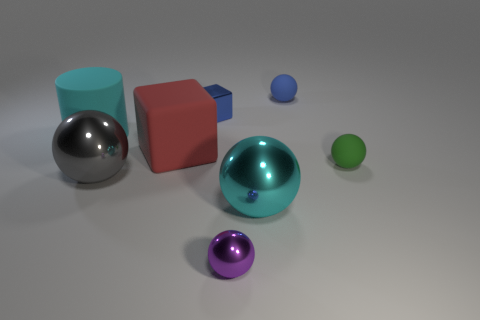Subtract all small matte balls. How many balls are left? 3 Add 1 big rubber cubes. How many objects exist? 9 Subtract all purple balls. How many balls are left? 4 Subtract 1 balls. How many balls are left? 4 Subtract all blocks. How many objects are left? 6 Subtract all red balls. Subtract all cyan cubes. How many balls are left? 5 Add 5 purple shiny things. How many purple shiny things are left? 6 Add 4 small rubber cylinders. How many small rubber cylinders exist? 4 Subtract 0 gray cylinders. How many objects are left? 8 Subtract all large blocks. Subtract all big cyan rubber things. How many objects are left? 6 